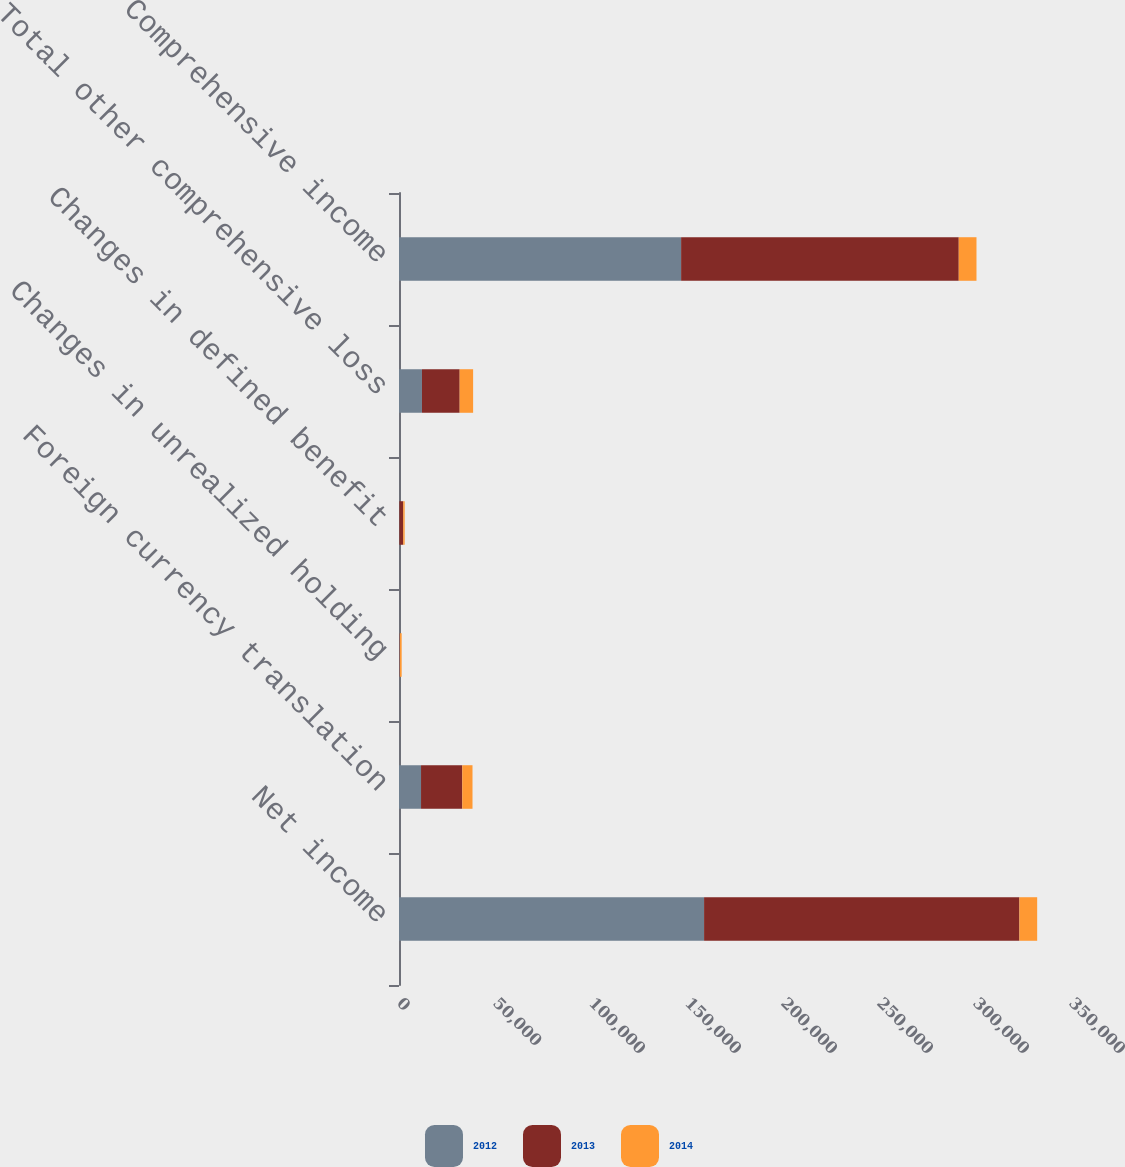<chart> <loc_0><loc_0><loc_500><loc_500><stacked_bar_chart><ecel><fcel>Net income<fcel>Foreign currency translation<fcel>Changes in unrealized holding<fcel>Changes in defined benefit<fcel>Total other comprehensive loss<fcel>Comprehensive income<nl><fcel>2012<fcel>158898<fcel>11476<fcel>305<fcel>183<fcel>11964<fcel>146934<nl><fcel>2013<fcel>164243<fcel>21470<fcel>180<fcel>2011<fcel>19639<fcel>144604<nl><fcel>2014<fcel>9239.5<fcel>5337<fcel>905<fcel>761<fcel>7003<fcel>9239.5<nl></chart> 